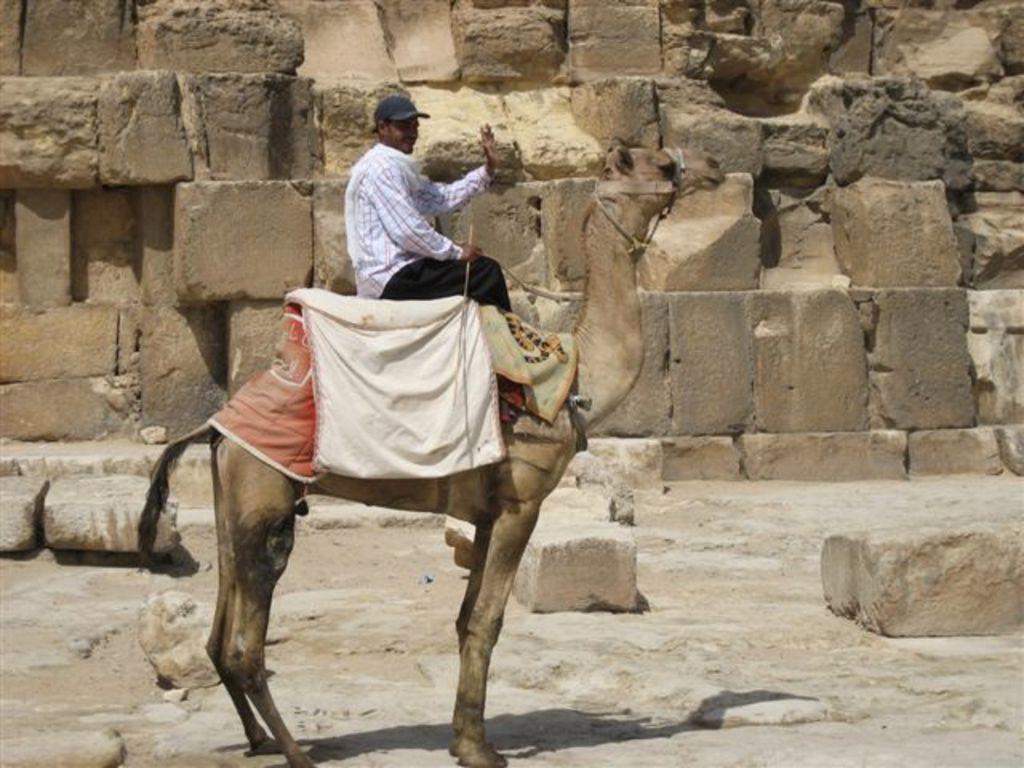Could you give a brief overview of what you see in this image? There is a person sitting on a camel in the foreground of the image and there are stones and a stone wall in the background area. 